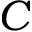Convert formula to latex. <formula><loc_0><loc_0><loc_500><loc_500>C</formula> 